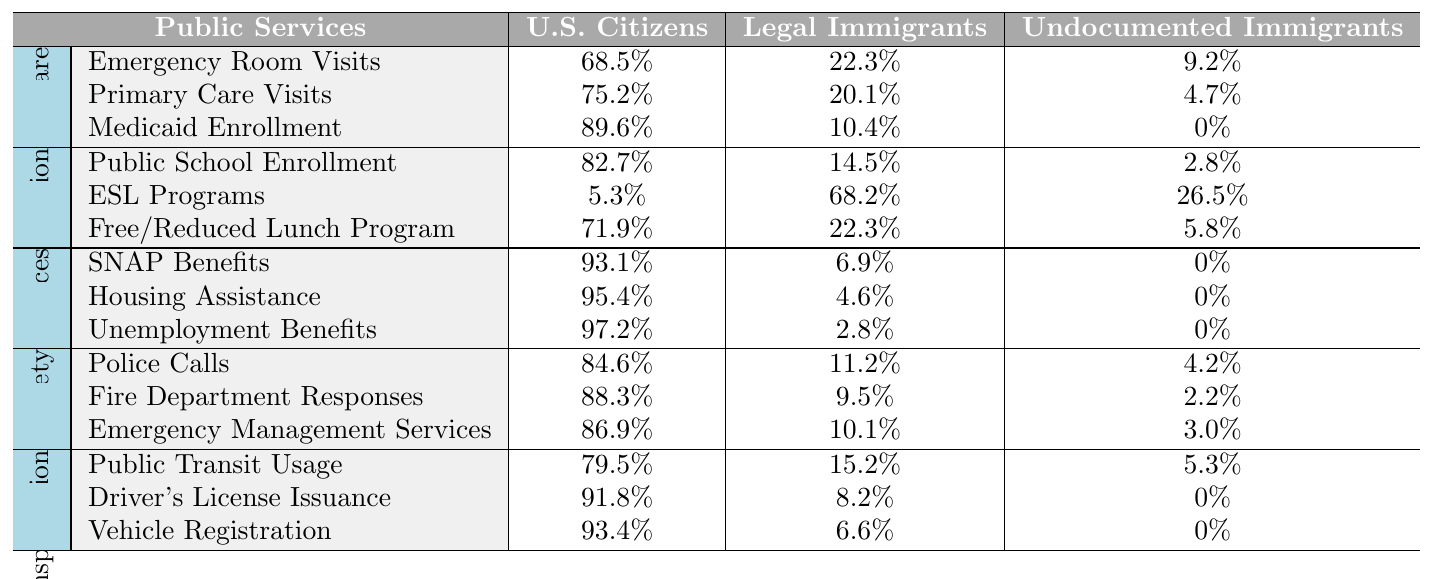What percentage of U.S. citizens utilize emergency room services? The table shows that 68.5% of U.S. Citizens use emergency room services under the healthcare section.
Answer: 68.5% How much higher is the percentage of U.S. citizens enrolled in Medicaid compared to legal immigrants? The enrollment percentage for U.S. citizens is 89.6% and for legal immigrants it is 10.4%. The difference is 89.6% - 10.4% = 79.2%.
Answer: 79.2% Do undocumented immigrants have access to SNAP benefits? According to the table, 0% of undocumented immigrants receive SNAP benefits, indicating they do not have access to this service.
Answer: No What is the total percentage of people enrolled in public school among U.S. citizens and legal immigrants? The percentage of U.S. citizens enrolled is 82.7%, and for legal immigrants, it is 14.5%. Adding these gives 82.7% + 14.5% = 97.2%.
Answer: 97.2% Which group has the highest percentage of free/reduced lunch program enrollment among legal immigrants and undocumented immigrants combined? For legal immigrants, it is 22.3% and for undocumented immigrants, it is 5.8%. The total is 22.3% + 5.8% = 28.1%. Legal immigrants have the highest percentage of 22.3%.
Answer: Legal immigrants What is the average percentage of police calls for U.S. citizens and legal immigrants? U.S. citizens account for 84.6% and legal immigrants for 11.2%. The average is (84.6% + 11.2%) / 2 = 47.9%.
Answer: 47.9% Is the percentage of legal immigrants using primary care services greater than the usage rate of undocumented immigrants? The usage rate for legal immigrants is 20.1% while for undocumented immigrants it is 4.7%. Since 20.1% is greater than 4.7%, it confirms that legal immigrants use primary care services more.
Answer: Yes What percentage of U.S. citizens use public transit compared to the total percentage of legal and undocumented immigrants? U.S. Citizens use 79.5% of public transit, while legal immigrants use 15.2% and undocumented immigrants use 5.3%. Together, legal and undocumented immigrants account for 15.2% + 5.3% = 20.5%. Comparing, 79.5% for U.S. citizens is significantly higher than 20.5%.
Answer: 79.5% Which public service has the highest percentage of usage by U.S. citizens? Looking at the table, Unemployment Benefits at 97.2% represents the highest percentage of service usage by U.S. citizens across all categories.
Answer: Unemployment Benefits What is the total percentage of fire department responses for U.S. citizens and legal immigrants? The responses are 88.3% for U.S. citizens and 9.5% for legal immigrants. Combining these percentages gives 88.3% + 9.5% = 97.8%.
Answer: 97.8% Is it true that undocumented immigrants have zero access to Medicaid enrollment? The table shows that Medicaid enrollment for undocumented immigrants is 0%, indicating they do not access it. Thus, it is true.
Answer: True 